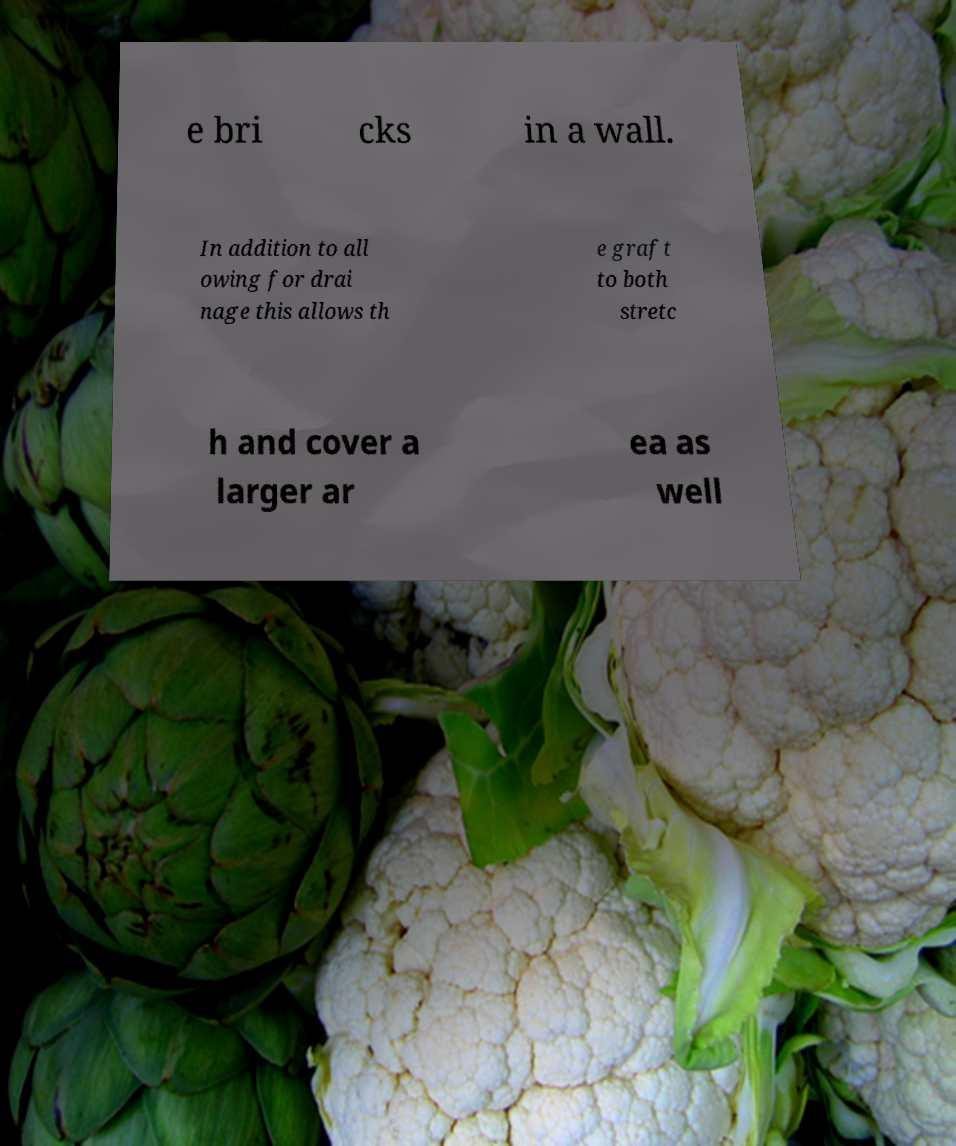For documentation purposes, I need the text within this image transcribed. Could you provide that? e bri cks in a wall. In addition to all owing for drai nage this allows th e graft to both stretc h and cover a larger ar ea as well 